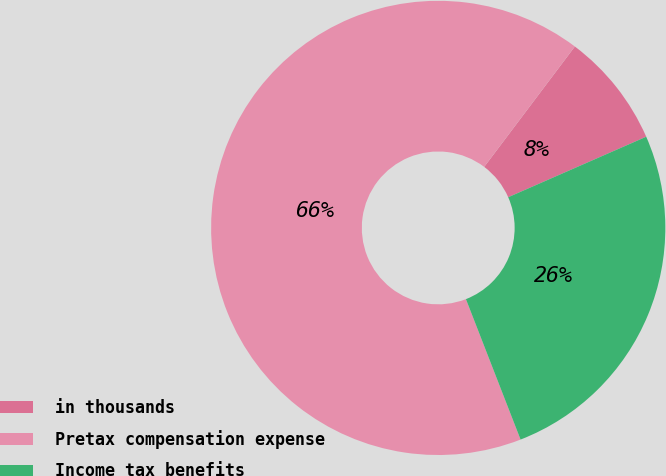Convert chart to OTSL. <chart><loc_0><loc_0><loc_500><loc_500><pie_chart><fcel>in thousands<fcel>Pretax compensation expense<fcel>Income tax benefits<nl><fcel>8.15%<fcel>66.18%<fcel>25.67%<nl></chart> 